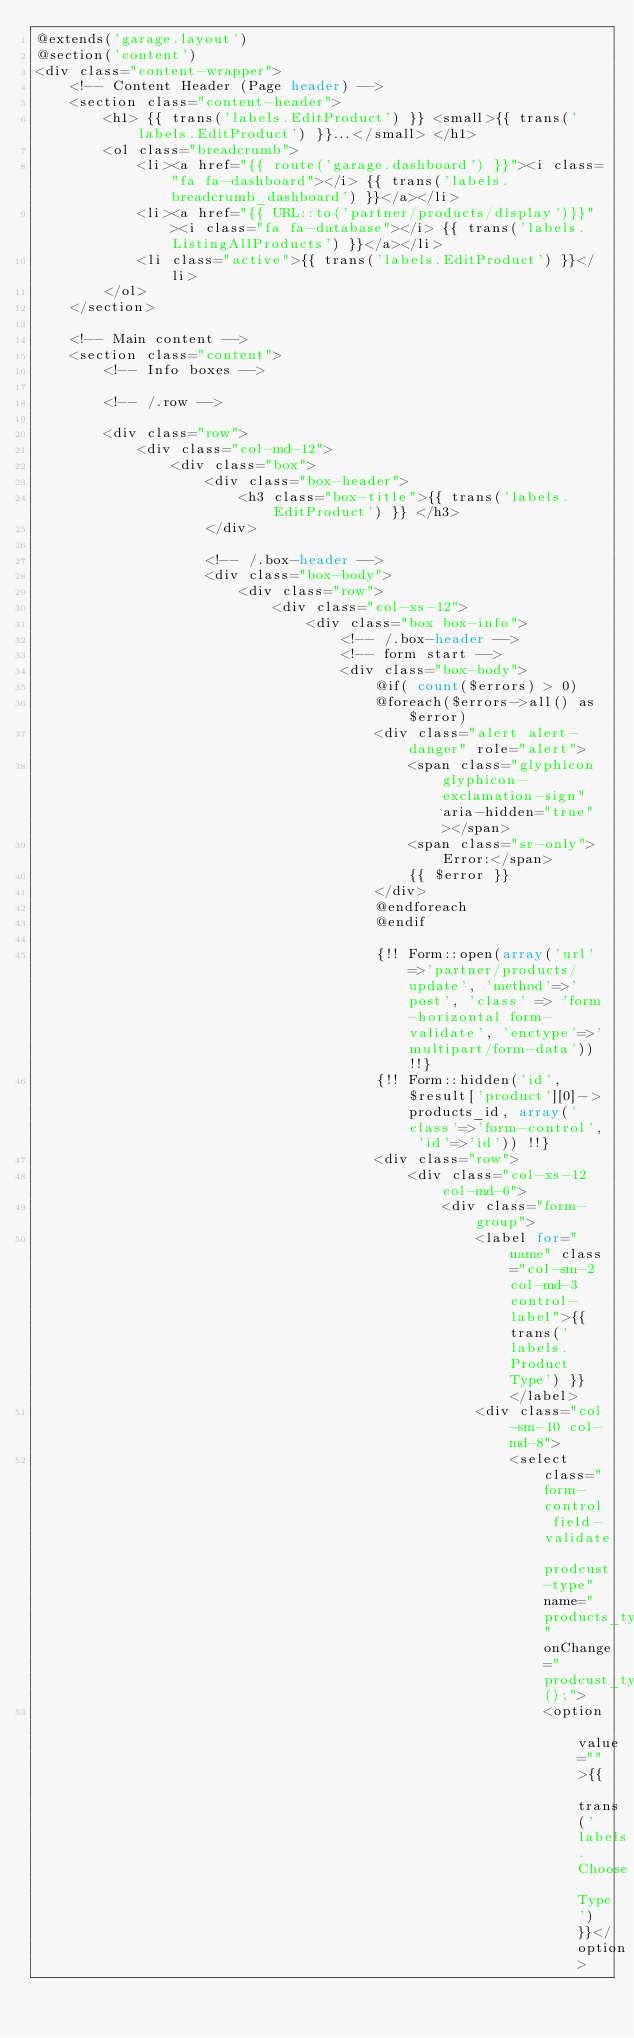Convert code to text. <code><loc_0><loc_0><loc_500><loc_500><_PHP_>@extends('garage.layout')
@section('content')
<div class="content-wrapper">
    <!-- Content Header (Page header) -->
    <section class="content-header">
        <h1> {{ trans('labels.EditProduct') }} <small>{{ trans('labels.EditProduct') }}...</small> </h1>
        <ol class="breadcrumb">
            <li><a href="{{ route('garage.dashboard') }}"><i class="fa fa-dashboard"></i> {{ trans('labels.breadcrumb_dashboard') }}</a></li>
            <li><a href="{{ URL::to('partner/products/display')}}"><i class="fa fa-database"></i> {{ trans('labels.ListingAllProducts') }}</a></li>
            <li class="active">{{ trans('labels.EditProduct') }}</li>
        </ol>
    </section>

    <!-- Main content -->
    <section class="content">
        <!-- Info boxes -->

        <!-- /.row -->

        <div class="row">
            <div class="col-md-12">
                <div class="box">
                    <div class="box-header">
                        <h3 class="box-title">{{ trans('labels.EditProduct') }} </h3>
                    </div>

                    <!-- /.box-header -->
                    <div class="box-body">
                        <div class="row">
                            <div class="col-xs-12">
                                <div class="box box-info">
                                    <!-- /.box-header -->
                                    <!-- form start -->
                                    <div class="box-body">
                                        @if( count($errors) > 0)
                                        @foreach($errors->all() as $error)
                                        <div class="alert alert-danger" role="alert">
                                            <span class="glyphicon glyphicon-exclamation-sign" aria-hidden="true"></span>
                                            <span class="sr-only">Error:</span>
                                            {{ $error }}
                                        </div>
                                        @endforeach
                                        @endif

                                        {!! Form::open(array('url' =>'partner/products/update', 'method'=>'post', 'class' => 'form-horizontal form-validate', 'enctype'=>'multipart/form-data')) !!}
                                        {!! Form::hidden('id', $result['product'][0]->products_id, array('class'=>'form-control', 'id'=>'id')) !!}
                                        <div class="row">
                                            <div class="col-xs-12 col-md-6">
                                                <div class="form-group">
                                                    <label for="name" class="col-sm-2 col-md-3 control-label">{{ trans('labels.Product Type') }} </label>
                                                    <div class="col-sm-10 col-md-8">
                                                        <select class="form-control field-validate prodcust-type" name="products_type" onChange="prodcust_type();">
                                                            <option value="">{{ trans('labels.Choose Type') }}</option></code> 